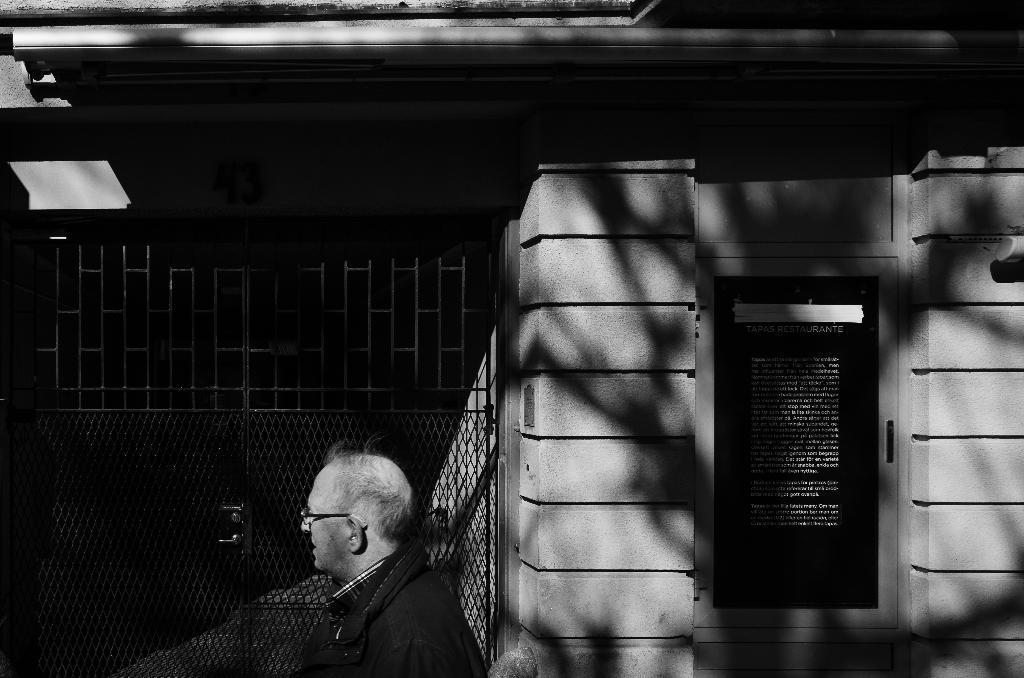Who or what is present in the image? There is a person in the image. What type of structure is visible in the image? There is a house in the image. Is there any entrance or exit feature in the image? Yes, there is a gate in the image. What is the purpose of the board with text in the image? The purpose of the board with text is not clear from the image, but it may contain information or a message. How is the image presented in terms of color? The image is in black and white mode. Where is the giraffe located in the image? There is no giraffe present in the image. What type of material is the basin made of in the image? There is no basin present in the image. 